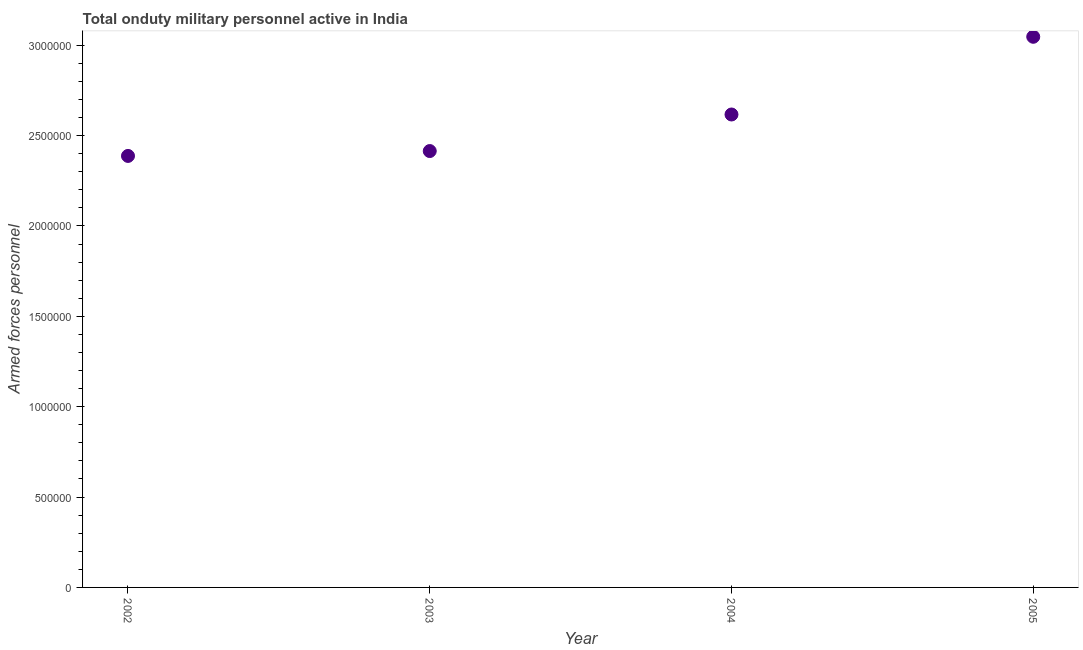What is the number of armed forces personnel in 2005?
Ensure brevity in your answer.  3.05e+06. Across all years, what is the maximum number of armed forces personnel?
Make the answer very short. 3.05e+06. Across all years, what is the minimum number of armed forces personnel?
Keep it short and to the point. 2.39e+06. In which year was the number of armed forces personnel minimum?
Make the answer very short. 2002. What is the sum of the number of armed forces personnel?
Offer a very short reply. 1.05e+07. What is the difference between the number of armed forces personnel in 2002 and 2005?
Your response must be concise. -6.59e+05. What is the average number of armed forces personnel per year?
Provide a succinct answer. 2.62e+06. What is the median number of armed forces personnel?
Your answer should be very brief. 2.52e+06. What is the ratio of the number of armed forces personnel in 2003 to that in 2005?
Ensure brevity in your answer.  0.79. Is the number of armed forces personnel in 2004 less than that in 2005?
Your answer should be very brief. Yes. Is the difference between the number of armed forces personnel in 2003 and 2005 greater than the difference between any two years?
Keep it short and to the point. No. What is the difference between the highest and the lowest number of armed forces personnel?
Give a very brief answer. 6.59e+05. In how many years, is the number of armed forces personnel greater than the average number of armed forces personnel taken over all years?
Your response must be concise. 2. Does the number of armed forces personnel monotonically increase over the years?
Make the answer very short. Yes. How many dotlines are there?
Give a very brief answer. 1. How many years are there in the graph?
Provide a short and direct response. 4. What is the difference between two consecutive major ticks on the Y-axis?
Offer a very short reply. 5.00e+05. What is the title of the graph?
Give a very brief answer. Total onduty military personnel active in India. What is the label or title of the Y-axis?
Keep it short and to the point. Armed forces personnel. What is the Armed forces personnel in 2002?
Provide a short and direct response. 2.39e+06. What is the Armed forces personnel in 2003?
Offer a terse response. 2.41e+06. What is the Armed forces personnel in 2004?
Give a very brief answer. 2.62e+06. What is the Armed forces personnel in 2005?
Offer a very short reply. 3.05e+06. What is the difference between the Armed forces personnel in 2002 and 2003?
Your answer should be very brief. -2.70e+04. What is the difference between the Armed forces personnel in 2002 and 2004?
Make the answer very short. -2.29e+05. What is the difference between the Armed forces personnel in 2002 and 2005?
Ensure brevity in your answer.  -6.59e+05. What is the difference between the Armed forces personnel in 2003 and 2004?
Your response must be concise. -2.02e+05. What is the difference between the Armed forces personnel in 2003 and 2005?
Give a very brief answer. -6.32e+05. What is the difference between the Armed forces personnel in 2004 and 2005?
Provide a short and direct response. -4.30e+05. What is the ratio of the Armed forces personnel in 2002 to that in 2003?
Ensure brevity in your answer.  0.99. What is the ratio of the Armed forces personnel in 2002 to that in 2004?
Keep it short and to the point. 0.91. What is the ratio of the Armed forces personnel in 2002 to that in 2005?
Make the answer very short. 0.78. What is the ratio of the Armed forces personnel in 2003 to that in 2004?
Give a very brief answer. 0.92. What is the ratio of the Armed forces personnel in 2003 to that in 2005?
Offer a terse response. 0.79. What is the ratio of the Armed forces personnel in 2004 to that in 2005?
Your answer should be compact. 0.86. 